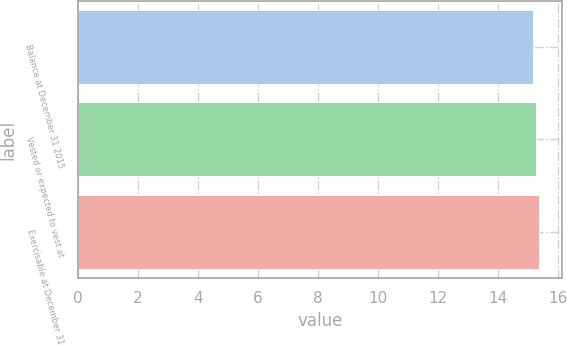Convert chart. <chart><loc_0><loc_0><loc_500><loc_500><bar_chart><fcel>Balance at December 31 2015<fcel>Vested or expected to vest at<fcel>Exercisable at December 31<nl><fcel>15.17<fcel>15.27<fcel>15.37<nl></chart> 